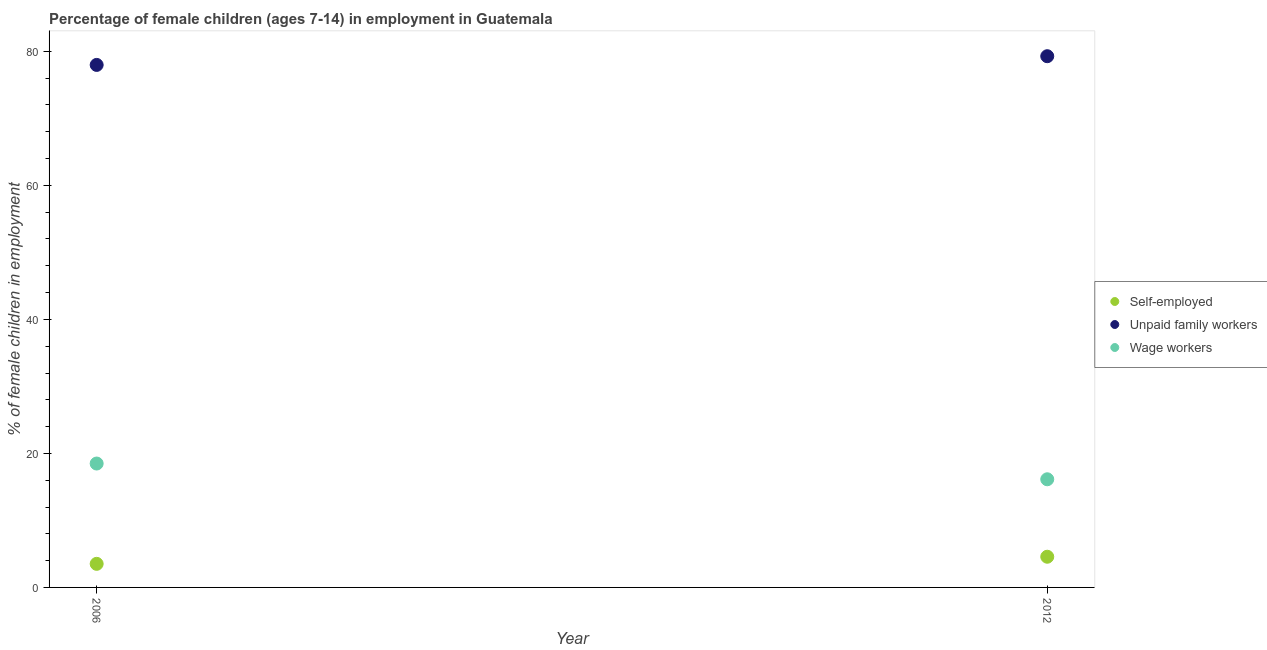Is the number of dotlines equal to the number of legend labels?
Offer a terse response. Yes. What is the percentage of children employed as wage workers in 2012?
Keep it short and to the point. 16.14. Across all years, what is the maximum percentage of self employed children?
Your response must be concise. 4.58. Across all years, what is the minimum percentage of children employed as unpaid family workers?
Offer a very short reply. 77.98. In which year was the percentage of self employed children maximum?
Offer a terse response. 2012. What is the total percentage of children employed as unpaid family workers in the graph?
Your answer should be compact. 157.26. What is the difference between the percentage of children employed as wage workers in 2006 and that in 2012?
Ensure brevity in your answer.  2.35. What is the difference between the percentage of self employed children in 2006 and the percentage of children employed as unpaid family workers in 2012?
Offer a terse response. -75.76. What is the average percentage of self employed children per year?
Make the answer very short. 4.05. In the year 2006, what is the difference between the percentage of children employed as unpaid family workers and percentage of children employed as wage workers?
Your response must be concise. 59.49. What is the ratio of the percentage of children employed as unpaid family workers in 2006 to that in 2012?
Provide a short and direct response. 0.98. In how many years, is the percentage of self employed children greater than the average percentage of self employed children taken over all years?
Give a very brief answer. 1. Is it the case that in every year, the sum of the percentage of self employed children and percentage of children employed as unpaid family workers is greater than the percentage of children employed as wage workers?
Your answer should be compact. Yes. Is the percentage of children employed as unpaid family workers strictly greater than the percentage of self employed children over the years?
Ensure brevity in your answer.  Yes. Is the percentage of self employed children strictly less than the percentage of children employed as wage workers over the years?
Your answer should be very brief. Yes. How many years are there in the graph?
Your answer should be very brief. 2. Does the graph contain any zero values?
Make the answer very short. No. Does the graph contain grids?
Ensure brevity in your answer.  No. How many legend labels are there?
Provide a short and direct response. 3. How are the legend labels stacked?
Offer a terse response. Vertical. What is the title of the graph?
Provide a short and direct response. Percentage of female children (ages 7-14) in employment in Guatemala. What is the label or title of the X-axis?
Your response must be concise. Year. What is the label or title of the Y-axis?
Your response must be concise. % of female children in employment. What is the % of female children in employment in Self-employed in 2006?
Provide a succinct answer. 3.52. What is the % of female children in employment of Unpaid family workers in 2006?
Your answer should be compact. 77.98. What is the % of female children in employment in Wage workers in 2006?
Make the answer very short. 18.49. What is the % of female children in employment in Self-employed in 2012?
Your response must be concise. 4.58. What is the % of female children in employment of Unpaid family workers in 2012?
Offer a terse response. 79.28. What is the % of female children in employment in Wage workers in 2012?
Give a very brief answer. 16.14. Across all years, what is the maximum % of female children in employment in Self-employed?
Offer a very short reply. 4.58. Across all years, what is the maximum % of female children in employment of Unpaid family workers?
Offer a terse response. 79.28. Across all years, what is the maximum % of female children in employment in Wage workers?
Give a very brief answer. 18.49. Across all years, what is the minimum % of female children in employment in Self-employed?
Provide a succinct answer. 3.52. Across all years, what is the minimum % of female children in employment of Unpaid family workers?
Your answer should be compact. 77.98. Across all years, what is the minimum % of female children in employment in Wage workers?
Your response must be concise. 16.14. What is the total % of female children in employment in Unpaid family workers in the graph?
Your answer should be very brief. 157.26. What is the total % of female children in employment in Wage workers in the graph?
Ensure brevity in your answer.  34.63. What is the difference between the % of female children in employment in Self-employed in 2006 and that in 2012?
Your answer should be very brief. -1.06. What is the difference between the % of female children in employment of Wage workers in 2006 and that in 2012?
Provide a succinct answer. 2.35. What is the difference between the % of female children in employment of Self-employed in 2006 and the % of female children in employment of Unpaid family workers in 2012?
Make the answer very short. -75.76. What is the difference between the % of female children in employment of Self-employed in 2006 and the % of female children in employment of Wage workers in 2012?
Make the answer very short. -12.62. What is the difference between the % of female children in employment of Unpaid family workers in 2006 and the % of female children in employment of Wage workers in 2012?
Offer a terse response. 61.84. What is the average % of female children in employment of Self-employed per year?
Ensure brevity in your answer.  4.05. What is the average % of female children in employment in Unpaid family workers per year?
Your answer should be very brief. 78.63. What is the average % of female children in employment of Wage workers per year?
Offer a terse response. 17.32. In the year 2006, what is the difference between the % of female children in employment in Self-employed and % of female children in employment in Unpaid family workers?
Make the answer very short. -74.46. In the year 2006, what is the difference between the % of female children in employment in Self-employed and % of female children in employment in Wage workers?
Your answer should be compact. -14.97. In the year 2006, what is the difference between the % of female children in employment of Unpaid family workers and % of female children in employment of Wage workers?
Your response must be concise. 59.49. In the year 2012, what is the difference between the % of female children in employment in Self-employed and % of female children in employment in Unpaid family workers?
Your answer should be very brief. -74.7. In the year 2012, what is the difference between the % of female children in employment in Self-employed and % of female children in employment in Wage workers?
Ensure brevity in your answer.  -11.56. In the year 2012, what is the difference between the % of female children in employment of Unpaid family workers and % of female children in employment of Wage workers?
Your answer should be very brief. 63.14. What is the ratio of the % of female children in employment of Self-employed in 2006 to that in 2012?
Keep it short and to the point. 0.77. What is the ratio of the % of female children in employment in Unpaid family workers in 2006 to that in 2012?
Your answer should be compact. 0.98. What is the ratio of the % of female children in employment in Wage workers in 2006 to that in 2012?
Provide a short and direct response. 1.15. What is the difference between the highest and the second highest % of female children in employment of Self-employed?
Provide a short and direct response. 1.06. What is the difference between the highest and the second highest % of female children in employment in Unpaid family workers?
Your answer should be very brief. 1.3. What is the difference between the highest and the second highest % of female children in employment of Wage workers?
Your response must be concise. 2.35. What is the difference between the highest and the lowest % of female children in employment of Self-employed?
Provide a succinct answer. 1.06. What is the difference between the highest and the lowest % of female children in employment in Unpaid family workers?
Give a very brief answer. 1.3. What is the difference between the highest and the lowest % of female children in employment in Wage workers?
Your answer should be very brief. 2.35. 